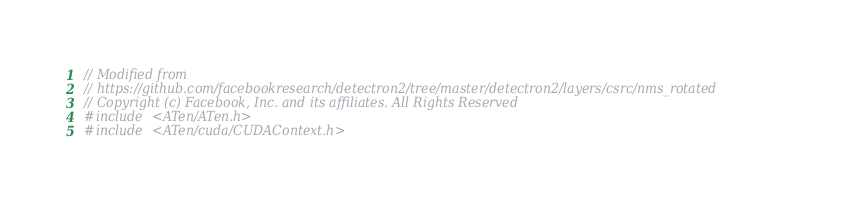Convert code to text. <code><loc_0><loc_0><loc_500><loc_500><_Cuda_>// Modified from
// https://github.com/facebookresearch/detectron2/tree/master/detectron2/layers/csrc/nms_rotated
// Copyright (c) Facebook, Inc. and its affiliates. All Rights Reserved
#include <ATen/ATen.h>
#include <ATen/cuda/CUDAContext.h></code> 